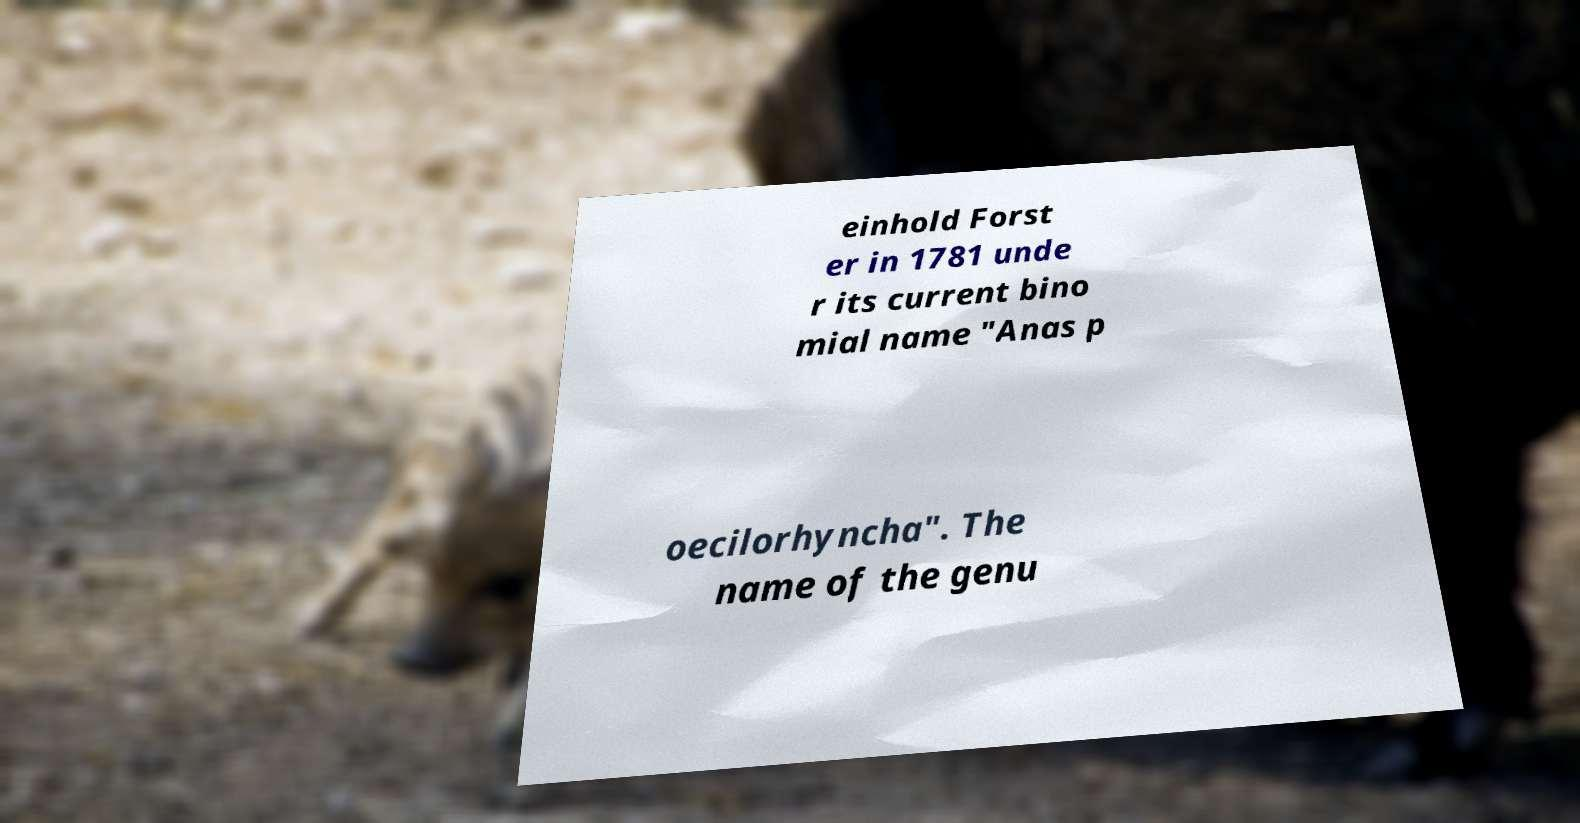For documentation purposes, I need the text within this image transcribed. Could you provide that? einhold Forst er in 1781 unde r its current bino mial name "Anas p oecilorhyncha". The name of the genu 